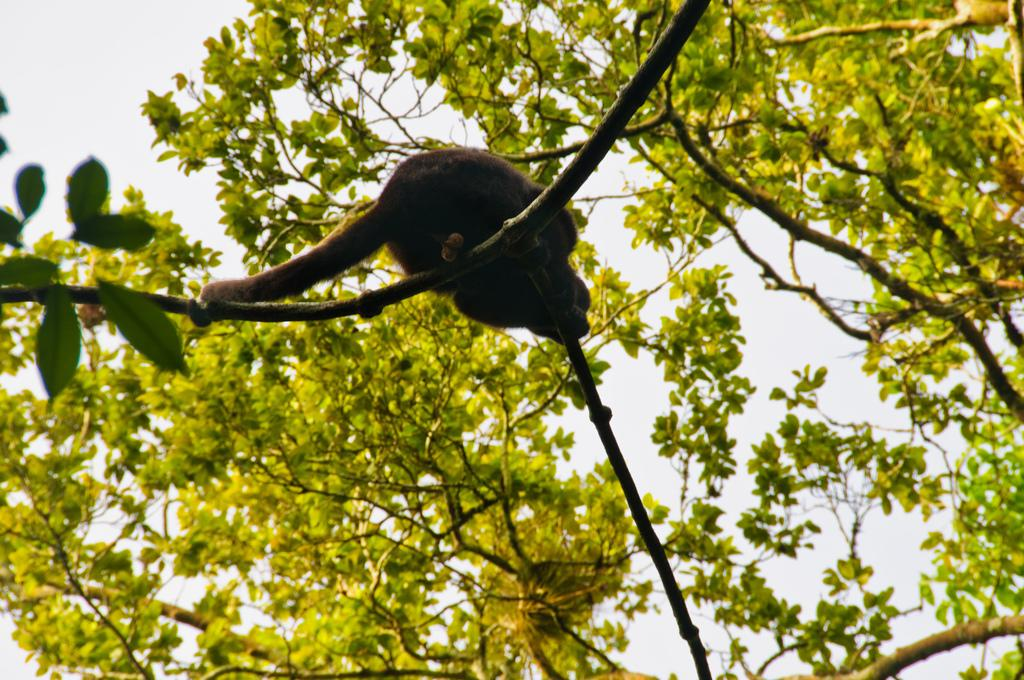What is on the tree in the image? There is an animal on a tree in the image. What can be seen in the background of the image? There are trees and the sky visible in the background of the image. Where is the pump located in the image? There is no pump present in the image. What type of drum can be seen in the image? There is no drum present in the image. 